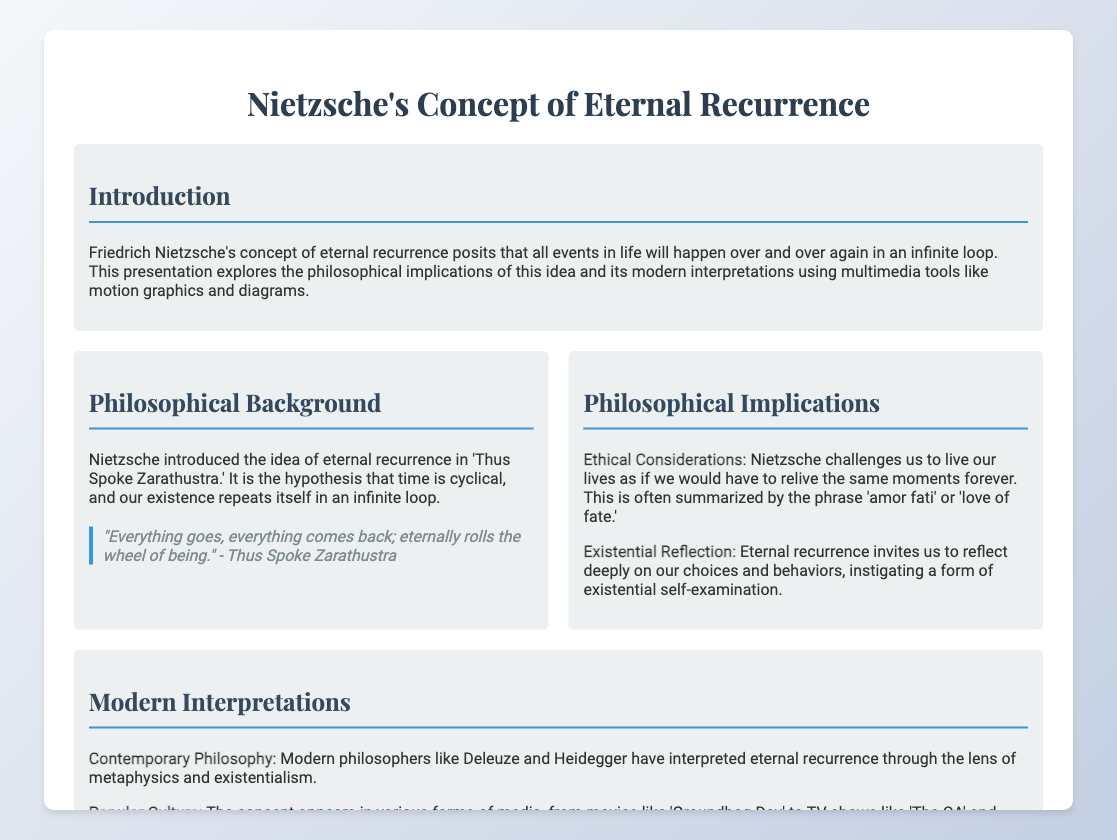What is the title of the presentation? The title is the main heading of the document, which introduces the central concept discussed.
Answer: Nietzsche's Concept of Eternal Recurrence Who introduced the idea of eternal recurrence? The document mentions Friedrich Nietzsche as the key figure behind this philosophical idea.
Answer: Friedrich Nietzsche What is the quote from 'Thus Spoke Zarathustra'? This quote illustrates Nietzsche's belief in cyclic existence and is featured prominently in the document.
Answer: "Everything goes, everything comes back; eternally rolls the wheel of being." What does 'amor fati' mean? The concept that encapsulates the ethical consideration of eternal recurrence is summarized in this phrase.
Answer: Love of fate Which contemporary philosopher is mentioned in the modern interpretations? The document lists modern philosophers who have explored Nietzsche's concept, highlighting their relevance to contemporary thought.
Answer: Deleuze What multimedia tool is mentioned for illustrating the cyclical nature of time? The presentation includes different multimedia elements that enhance understanding, specifically one tool that visually represents the concept.
Answer: Motion Graphics What does the diagram represent in the multimedia enhancements section? The use of diagrams is to provide a visual representation that explains a specific philosophical idea.
Answer: Flowchart: Philosophical Implications In what year was the idea of eternal recurrence introduced? The document refers to the work in which the concept first appeared, providing a timeframe for its introduction.
Answer: Thus Spoke Zarathustra What is the primary challenge posed by Nietzsche’s theory? The conclusion summarizes the intellectual challenge that the concept of eternal recurrence presents to individuals.
Answer: Profound philosophical challenge 